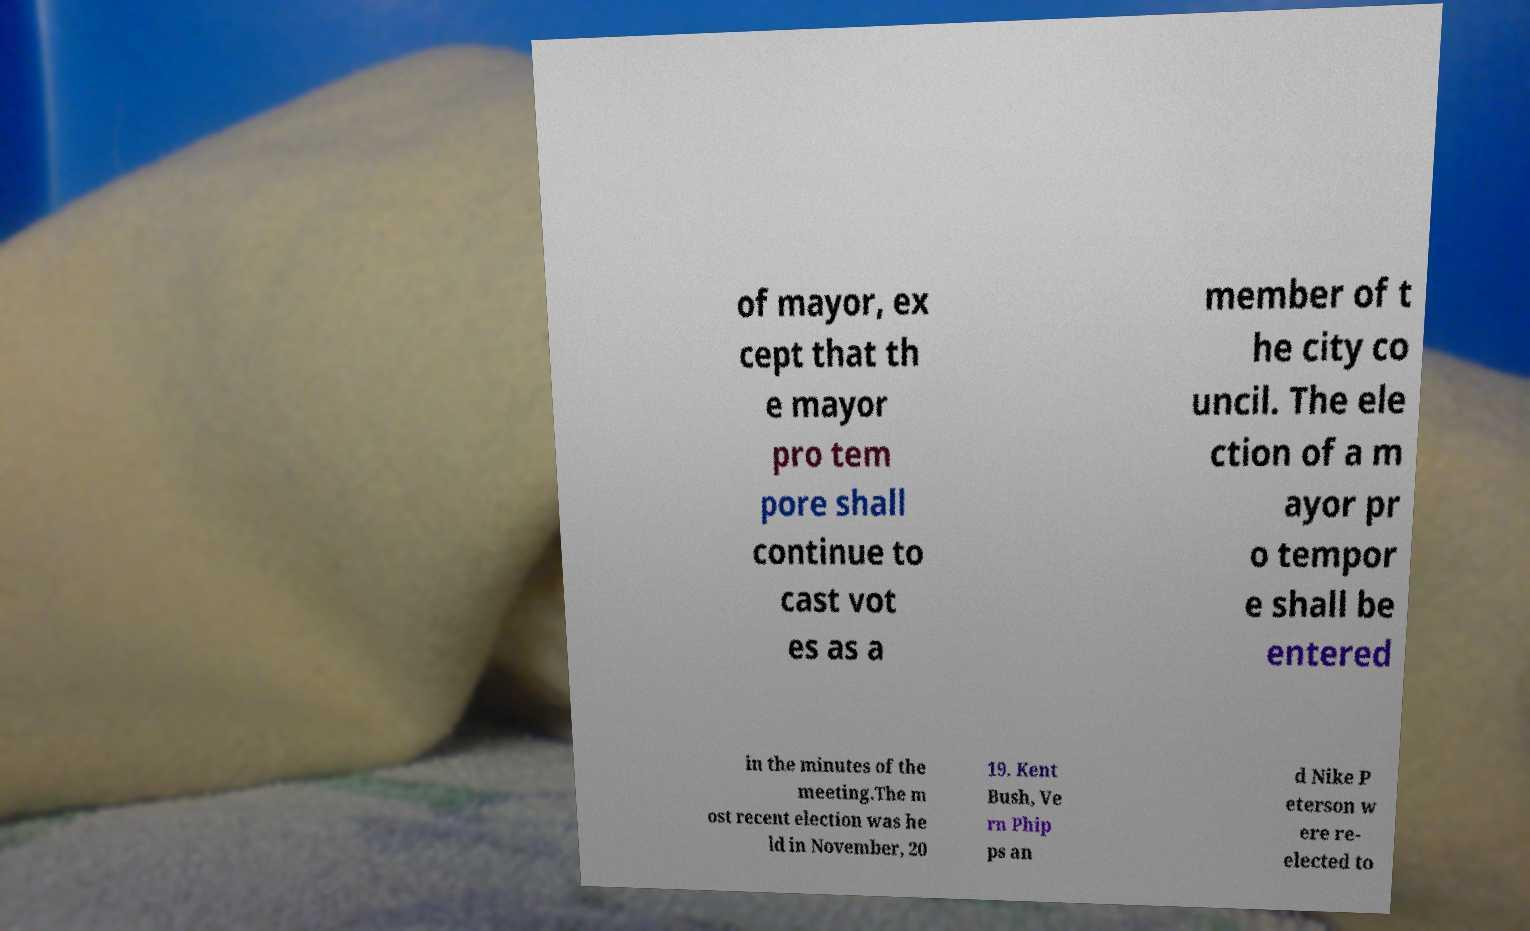Could you extract and type out the text from this image? of mayor, ex cept that th e mayor pro tem pore shall continue to cast vot es as a member of t he city co uncil. The ele ction of a m ayor pr o tempor e shall be entered in the minutes of the meeting.The m ost recent election was he ld in November, 20 19. Kent Bush, Ve rn Phip ps an d Nike P eterson w ere re- elected to 